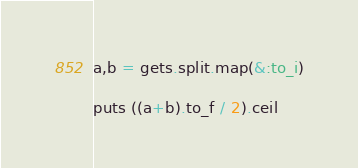<code> <loc_0><loc_0><loc_500><loc_500><_Ruby_>a,b = gets.split.map(&:to_i)

puts ((a+b).to_f / 2).ceil</code> 